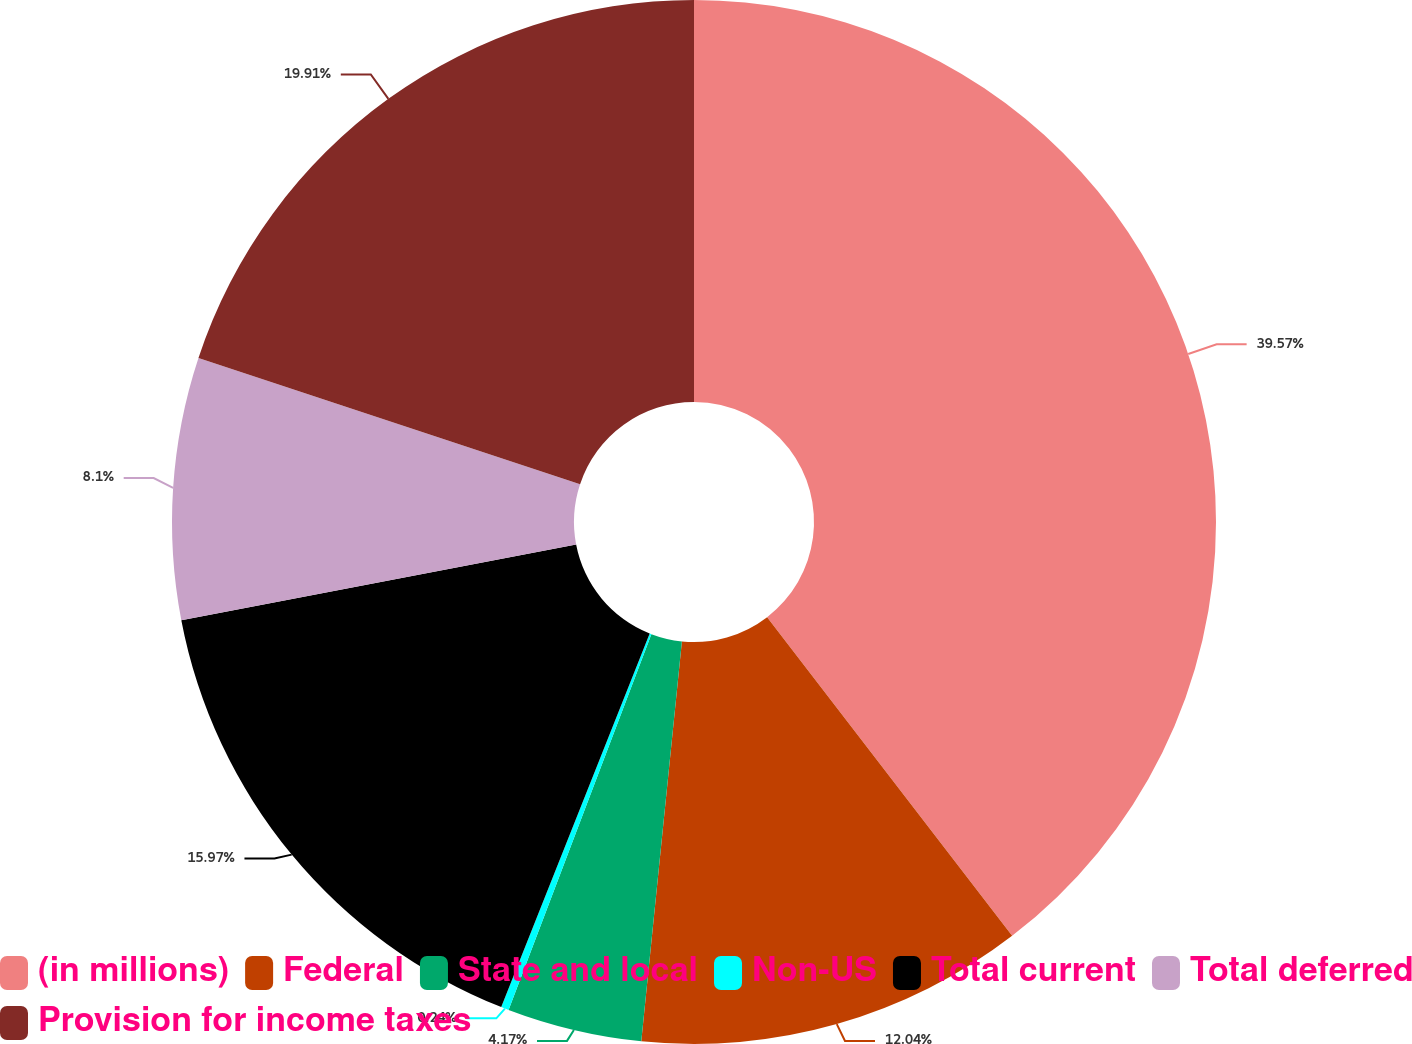Convert chart to OTSL. <chart><loc_0><loc_0><loc_500><loc_500><pie_chart><fcel>(in millions)<fcel>Federal<fcel>State and local<fcel>Non-US<fcel>Total current<fcel>Total deferred<fcel>Provision for income taxes<nl><fcel>39.57%<fcel>12.04%<fcel>4.17%<fcel>0.24%<fcel>15.97%<fcel>8.1%<fcel>19.91%<nl></chart> 